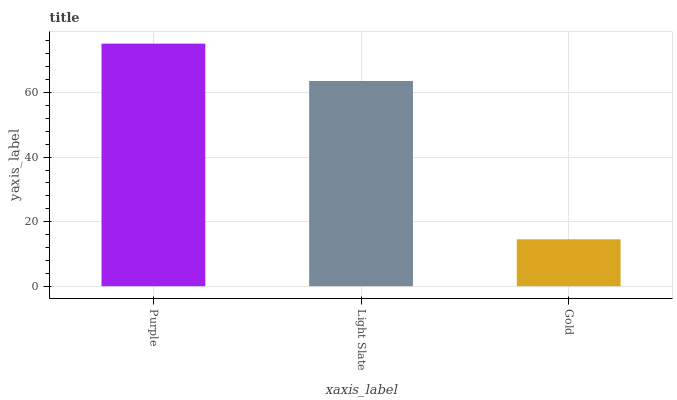Is Light Slate the minimum?
Answer yes or no. No. Is Light Slate the maximum?
Answer yes or no. No. Is Purple greater than Light Slate?
Answer yes or no. Yes. Is Light Slate less than Purple?
Answer yes or no. Yes. Is Light Slate greater than Purple?
Answer yes or no. No. Is Purple less than Light Slate?
Answer yes or no. No. Is Light Slate the high median?
Answer yes or no. Yes. Is Light Slate the low median?
Answer yes or no. Yes. Is Purple the high median?
Answer yes or no. No. Is Purple the low median?
Answer yes or no. No. 